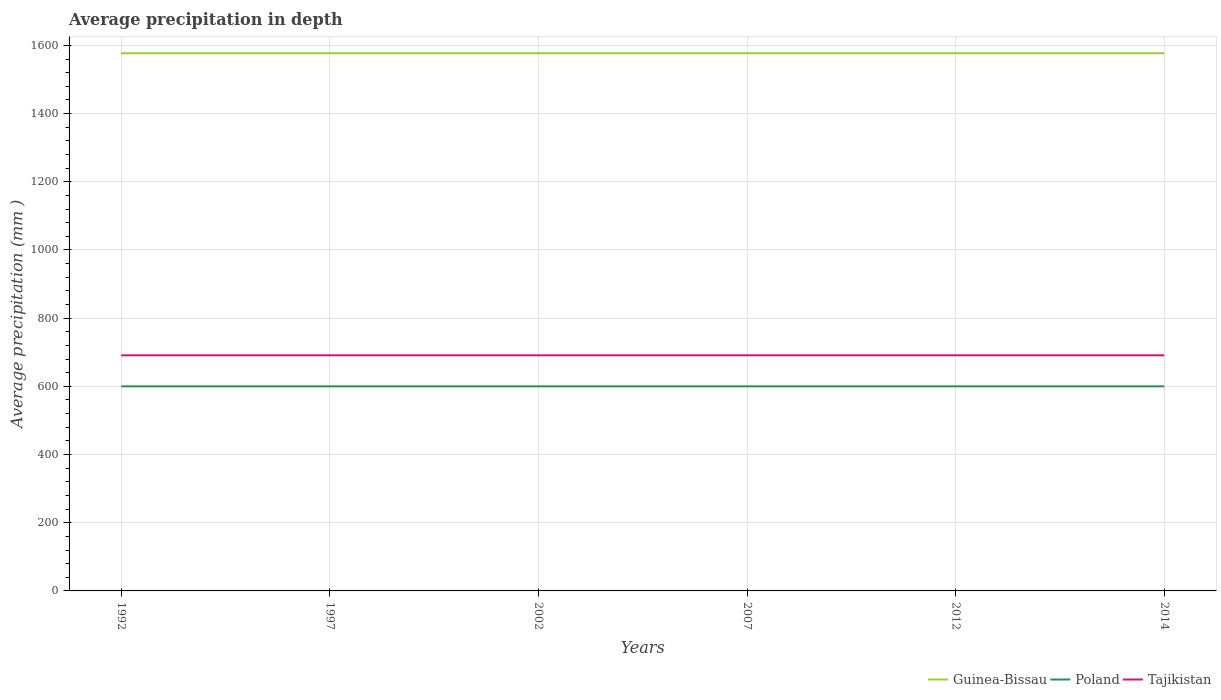How many different coloured lines are there?
Offer a very short reply. 3. Does the line corresponding to Poland intersect with the line corresponding to Tajikistan?
Give a very brief answer. No. Is the number of lines equal to the number of legend labels?
Your answer should be very brief. Yes. Across all years, what is the maximum average precipitation in Tajikistan?
Your answer should be very brief. 691. What is the difference between the highest and the second highest average precipitation in Tajikistan?
Give a very brief answer. 0. What is the difference between the highest and the lowest average precipitation in Poland?
Provide a succinct answer. 0. How many lines are there?
Give a very brief answer. 3. How many years are there in the graph?
Your answer should be very brief. 6. What is the difference between two consecutive major ticks on the Y-axis?
Your answer should be very brief. 200. Does the graph contain any zero values?
Ensure brevity in your answer.  No. Where does the legend appear in the graph?
Provide a short and direct response. Bottom right. How many legend labels are there?
Your response must be concise. 3. How are the legend labels stacked?
Your response must be concise. Horizontal. What is the title of the graph?
Your response must be concise. Average precipitation in depth. What is the label or title of the Y-axis?
Your answer should be very brief. Average precipitation (mm ). What is the Average precipitation (mm ) in Guinea-Bissau in 1992?
Your answer should be very brief. 1577. What is the Average precipitation (mm ) in Poland in 1992?
Provide a succinct answer. 600. What is the Average precipitation (mm ) in Tajikistan in 1992?
Keep it short and to the point. 691. What is the Average precipitation (mm ) in Guinea-Bissau in 1997?
Ensure brevity in your answer.  1577. What is the Average precipitation (mm ) in Poland in 1997?
Provide a short and direct response. 600. What is the Average precipitation (mm ) of Tajikistan in 1997?
Offer a very short reply. 691. What is the Average precipitation (mm ) of Guinea-Bissau in 2002?
Keep it short and to the point. 1577. What is the Average precipitation (mm ) of Poland in 2002?
Your answer should be very brief. 600. What is the Average precipitation (mm ) of Tajikistan in 2002?
Offer a terse response. 691. What is the Average precipitation (mm ) in Guinea-Bissau in 2007?
Keep it short and to the point. 1577. What is the Average precipitation (mm ) of Poland in 2007?
Make the answer very short. 600. What is the Average precipitation (mm ) in Tajikistan in 2007?
Make the answer very short. 691. What is the Average precipitation (mm ) in Guinea-Bissau in 2012?
Give a very brief answer. 1577. What is the Average precipitation (mm ) in Poland in 2012?
Offer a terse response. 600. What is the Average precipitation (mm ) of Tajikistan in 2012?
Your answer should be compact. 691. What is the Average precipitation (mm ) in Guinea-Bissau in 2014?
Keep it short and to the point. 1577. What is the Average precipitation (mm ) of Poland in 2014?
Offer a terse response. 600. What is the Average precipitation (mm ) in Tajikistan in 2014?
Your response must be concise. 691. Across all years, what is the maximum Average precipitation (mm ) in Guinea-Bissau?
Give a very brief answer. 1577. Across all years, what is the maximum Average precipitation (mm ) of Poland?
Offer a very short reply. 600. Across all years, what is the maximum Average precipitation (mm ) in Tajikistan?
Make the answer very short. 691. Across all years, what is the minimum Average precipitation (mm ) of Guinea-Bissau?
Your answer should be compact. 1577. Across all years, what is the minimum Average precipitation (mm ) in Poland?
Your answer should be compact. 600. Across all years, what is the minimum Average precipitation (mm ) in Tajikistan?
Provide a succinct answer. 691. What is the total Average precipitation (mm ) of Guinea-Bissau in the graph?
Offer a very short reply. 9462. What is the total Average precipitation (mm ) of Poland in the graph?
Ensure brevity in your answer.  3600. What is the total Average precipitation (mm ) in Tajikistan in the graph?
Make the answer very short. 4146. What is the difference between the Average precipitation (mm ) of Guinea-Bissau in 1992 and that in 2002?
Provide a short and direct response. 0. What is the difference between the Average precipitation (mm ) of Poland in 1992 and that in 2002?
Provide a succinct answer. 0. What is the difference between the Average precipitation (mm ) of Tajikistan in 1992 and that in 2002?
Make the answer very short. 0. What is the difference between the Average precipitation (mm ) in Poland in 1992 and that in 2007?
Provide a short and direct response. 0. What is the difference between the Average precipitation (mm ) in Tajikistan in 1992 and that in 2007?
Give a very brief answer. 0. What is the difference between the Average precipitation (mm ) in Guinea-Bissau in 1992 and that in 2012?
Offer a very short reply. 0. What is the difference between the Average precipitation (mm ) in Poland in 1992 and that in 2012?
Your answer should be compact. 0. What is the difference between the Average precipitation (mm ) in Tajikistan in 1992 and that in 2012?
Your answer should be very brief. 0. What is the difference between the Average precipitation (mm ) of Guinea-Bissau in 1992 and that in 2014?
Give a very brief answer. 0. What is the difference between the Average precipitation (mm ) in Poland in 1992 and that in 2014?
Provide a short and direct response. 0. What is the difference between the Average precipitation (mm ) of Tajikistan in 1992 and that in 2014?
Make the answer very short. 0. What is the difference between the Average precipitation (mm ) of Guinea-Bissau in 1997 and that in 2002?
Your answer should be very brief. 0. What is the difference between the Average precipitation (mm ) in Poland in 1997 and that in 2007?
Ensure brevity in your answer.  0. What is the difference between the Average precipitation (mm ) of Guinea-Bissau in 1997 and that in 2012?
Provide a succinct answer. 0. What is the difference between the Average precipitation (mm ) of Poland in 1997 and that in 2012?
Provide a short and direct response. 0. What is the difference between the Average precipitation (mm ) in Guinea-Bissau in 1997 and that in 2014?
Offer a terse response. 0. What is the difference between the Average precipitation (mm ) in Poland in 1997 and that in 2014?
Give a very brief answer. 0. What is the difference between the Average precipitation (mm ) of Tajikistan in 1997 and that in 2014?
Keep it short and to the point. 0. What is the difference between the Average precipitation (mm ) in Poland in 2002 and that in 2007?
Your answer should be compact. 0. What is the difference between the Average precipitation (mm ) of Tajikistan in 2002 and that in 2007?
Your answer should be compact. 0. What is the difference between the Average precipitation (mm ) of Guinea-Bissau in 2002 and that in 2012?
Your answer should be compact. 0. What is the difference between the Average precipitation (mm ) in Poland in 2002 and that in 2012?
Keep it short and to the point. 0. What is the difference between the Average precipitation (mm ) in Tajikistan in 2002 and that in 2012?
Provide a succinct answer. 0. What is the difference between the Average precipitation (mm ) of Guinea-Bissau in 2007 and that in 2014?
Provide a succinct answer. 0. What is the difference between the Average precipitation (mm ) of Guinea-Bissau in 1992 and the Average precipitation (mm ) of Poland in 1997?
Provide a succinct answer. 977. What is the difference between the Average precipitation (mm ) of Guinea-Bissau in 1992 and the Average precipitation (mm ) of Tajikistan in 1997?
Give a very brief answer. 886. What is the difference between the Average precipitation (mm ) of Poland in 1992 and the Average precipitation (mm ) of Tajikistan in 1997?
Your answer should be compact. -91. What is the difference between the Average precipitation (mm ) of Guinea-Bissau in 1992 and the Average precipitation (mm ) of Poland in 2002?
Give a very brief answer. 977. What is the difference between the Average precipitation (mm ) of Guinea-Bissau in 1992 and the Average precipitation (mm ) of Tajikistan in 2002?
Your answer should be compact. 886. What is the difference between the Average precipitation (mm ) of Poland in 1992 and the Average precipitation (mm ) of Tajikistan in 2002?
Make the answer very short. -91. What is the difference between the Average precipitation (mm ) of Guinea-Bissau in 1992 and the Average precipitation (mm ) of Poland in 2007?
Offer a terse response. 977. What is the difference between the Average precipitation (mm ) in Guinea-Bissau in 1992 and the Average precipitation (mm ) in Tajikistan in 2007?
Make the answer very short. 886. What is the difference between the Average precipitation (mm ) in Poland in 1992 and the Average precipitation (mm ) in Tajikistan in 2007?
Offer a very short reply. -91. What is the difference between the Average precipitation (mm ) of Guinea-Bissau in 1992 and the Average precipitation (mm ) of Poland in 2012?
Offer a terse response. 977. What is the difference between the Average precipitation (mm ) of Guinea-Bissau in 1992 and the Average precipitation (mm ) of Tajikistan in 2012?
Your answer should be compact. 886. What is the difference between the Average precipitation (mm ) of Poland in 1992 and the Average precipitation (mm ) of Tajikistan in 2012?
Make the answer very short. -91. What is the difference between the Average precipitation (mm ) in Guinea-Bissau in 1992 and the Average precipitation (mm ) in Poland in 2014?
Provide a succinct answer. 977. What is the difference between the Average precipitation (mm ) of Guinea-Bissau in 1992 and the Average precipitation (mm ) of Tajikistan in 2014?
Give a very brief answer. 886. What is the difference between the Average precipitation (mm ) in Poland in 1992 and the Average precipitation (mm ) in Tajikistan in 2014?
Your answer should be compact. -91. What is the difference between the Average precipitation (mm ) in Guinea-Bissau in 1997 and the Average precipitation (mm ) in Poland in 2002?
Make the answer very short. 977. What is the difference between the Average precipitation (mm ) of Guinea-Bissau in 1997 and the Average precipitation (mm ) of Tajikistan in 2002?
Your answer should be very brief. 886. What is the difference between the Average precipitation (mm ) of Poland in 1997 and the Average precipitation (mm ) of Tajikistan in 2002?
Offer a very short reply. -91. What is the difference between the Average precipitation (mm ) in Guinea-Bissau in 1997 and the Average precipitation (mm ) in Poland in 2007?
Ensure brevity in your answer.  977. What is the difference between the Average precipitation (mm ) in Guinea-Bissau in 1997 and the Average precipitation (mm ) in Tajikistan in 2007?
Keep it short and to the point. 886. What is the difference between the Average precipitation (mm ) in Poland in 1997 and the Average precipitation (mm ) in Tajikistan in 2007?
Your response must be concise. -91. What is the difference between the Average precipitation (mm ) in Guinea-Bissau in 1997 and the Average precipitation (mm ) in Poland in 2012?
Provide a succinct answer. 977. What is the difference between the Average precipitation (mm ) in Guinea-Bissau in 1997 and the Average precipitation (mm ) in Tajikistan in 2012?
Ensure brevity in your answer.  886. What is the difference between the Average precipitation (mm ) in Poland in 1997 and the Average precipitation (mm ) in Tajikistan in 2012?
Your response must be concise. -91. What is the difference between the Average precipitation (mm ) in Guinea-Bissau in 1997 and the Average precipitation (mm ) in Poland in 2014?
Provide a succinct answer. 977. What is the difference between the Average precipitation (mm ) of Guinea-Bissau in 1997 and the Average precipitation (mm ) of Tajikistan in 2014?
Keep it short and to the point. 886. What is the difference between the Average precipitation (mm ) in Poland in 1997 and the Average precipitation (mm ) in Tajikistan in 2014?
Ensure brevity in your answer.  -91. What is the difference between the Average precipitation (mm ) of Guinea-Bissau in 2002 and the Average precipitation (mm ) of Poland in 2007?
Keep it short and to the point. 977. What is the difference between the Average precipitation (mm ) in Guinea-Bissau in 2002 and the Average precipitation (mm ) in Tajikistan in 2007?
Keep it short and to the point. 886. What is the difference between the Average precipitation (mm ) of Poland in 2002 and the Average precipitation (mm ) of Tajikistan in 2007?
Ensure brevity in your answer.  -91. What is the difference between the Average precipitation (mm ) of Guinea-Bissau in 2002 and the Average precipitation (mm ) of Poland in 2012?
Your response must be concise. 977. What is the difference between the Average precipitation (mm ) in Guinea-Bissau in 2002 and the Average precipitation (mm ) in Tajikistan in 2012?
Your answer should be very brief. 886. What is the difference between the Average precipitation (mm ) of Poland in 2002 and the Average precipitation (mm ) of Tajikistan in 2012?
Provide a short and direct response. -91. What is the difference between the Average precipitation (mm ) of Guinea-Bissau in 2002 and the Average precipitation (mm ) of Poland in 2014?
Keep it short and to the point. 977. What is the difference between the Average precipitation (mm ) of Guinea-Bissau in 2002 and the Average precipitation (mm ) of Tajikistan in 2014?
Your answer should be very brief. 886. What is the difference between the Average precipitation (mm ) of Poland in 2002 and the Average precipitation (mm ) of Tajikistan in 2014?
Make the answer very short. -91. What is the difference between the Average precipitation (mm ) of Guinea-Bissau in 2007 and the Average precipitation (mm ) of Poland in 2012?
Your answer should be compact. 977. What is the difference between the Average precipitation (mm ) in Guinea-Bissau in 2007 and the Average precipitation (mm ) in Tajikistan in 2012?
Keep it short and to the point. 886. What is the difference between the Average precipitation (mm ) of Poland in 2007 and the Average precipitation (mm ) of Tajikistan in 2012?
Make the answer very short. -91. What is the difference between the Average precipitation (mm ) of Guinea-Bissau in 2007 and the Average precipitation (mm ) of Poland in 2014?
Offer a very short reply. 977. What is the difference between the Average precipitation (mm ) in Guinea-Bissau in 2007 and the Average precipitation (mm ) in Tajikistan in 2014?
Your response must be concise. 886. What is the difference between the Average precipitation (mm ) of Poland in 2007 and the Average precipitation (mm ) of Tajikistan in 2014?
Your response must be concise. -91. What is the difference between the Average precipitation (mm ) in Guinea-Bissau in 2012 and the Average precipitation (mm ) in Poland in 2014?
Keep it short and to the point. 977. What is the difference between the Average precipitation (mm ) of Guinea-Bissau in 2012 and the Average precipitation (mm ) of Tajikistan in 2014?
Offer a terse response. 886. What is the difference between the Average precipitation (mm ) in Poland in 2012 and the Average precipitation (mm ) in Tajikistan in 2014?
Offer a very short reply. -91. What is the average Average precipitation (mm ) of Guinea-Bissau per year?
Your answer should be very brief. 1577. What is the average Average precipitation (mm ) of Poland per year?
Give a very brief answer. 600. What is the average Average precipitation (mm ) of Tajikistan per year?
Offer a very short reply. 691. In the year 1992, what is the difference between the Average precipitation (mm ) in Guinea-Bissau and Average precipitation (mm ) in Poland?
Offer a terse response. 977. In the year 1992, what is the difference between the Average precipitation (mm ) in Guinea-Bissau and Average precipitation (mm ) in Tajikistan?
Your response must be concise. 886. In the year 1992, what is the difference between the Average precipitation (mm ) of Poland and Average precipitation (mm ) of Tajikistan?
Offer a very short reply. -91. In the year 1997, what is the difference between the Average precipitation (mm ) of Guinea-Bissau and Average precipitation (mm ) of Poland?
Make the answer very short. 977. In the year 1997, what is the difference between the Average precipitation (mm ) in Guinea-Bissau and Average precipitation (mm ) in Tajikistan?
Your answer should be very brief. 886. In the year 1997, what is the difference between the Average precipitation (mm ) in Poland and Average precipitation (mm ) in Tajikistan?
Give a very brief answer. -91. In the year 2002, what is the difference between the Average precipitation (mm ) of Guinea-Bissau and Average precipitation (mm ) of Poland?
Your response must be concise. 977. In the year 2002, what is the difference between the Average precipitation (mm ) in Guinea-Bissau and Average precipitation (mm ) in Tajikistan?
Offer a terse response. 886. In the year 2002, what is the difference between the Average precipitation (mm ) in Poland and Average precipitation (mm ) in Tajikistan?
Your answer should be compact. -91. In the year 2007, what is the difference between the Average precipitation (mm ) in Guinea-Bissau and Average precipitation (mm ) in Poland?
Make the answer very short. 977. In the year 2007, what is the difference between the Average precipitation (mm ) in Guinea-Bissau and Average precipitation (mm ) in Tajikistan?
Provide a short and direct response. 886. In the year 2007, what is the difference between the Average precipitation (mm ) of Poland and Average precipitation (mm ) of Tajikistan?
Offer a terse response. -91. In the year 2012, what is the difference between the Average precipitation (mm ) in Guinea-Bissau and Average precipitation (mm ) in Poland?
Offer a very short reply. 977. In the year 2012, what is the difference between the Average precipitation (mm ) in Guinea-Bissau and Average precipitation (mm ) in Tajikistan?
Make the answer very short. 886. In the year 2012, what is the difference between the Average precipitation (mm ) in Poland and Average precipitation (mm ) in Tajikistan?
Make the answer very short. -91. In the year 2014, what is the difference between the Average precipitation (mm ) in Guinea-Bissau and Average precipitation (mm ) in Poland?
Give a very brief answer. 977. In the year 2014, what is the difference between the Average precipitation (mm ) of Guinea-Bissau and Average precipitation (mm ) of Tajikistan?
Your answer should be very brief. 886. In the year 2014, what is the difference between the Average precipitation (mm ) in Poland and Average precipitation (mm ) in Tajikistan?
Provide a short and direct response. -91. What is the ratio of the Average precipitation (mm ) of Guinea-Bissau in 1992 to that in 2002?
Offer a very short reply. 1. What is the ratio of the Average precipitation (mm ) in Poland in 1992 to that in 2002?
Offer a very short reply. 1. What is the ratio of the Average precipitation (mm ) in Tajikistan in 1992 to that in 2002?
Give a very brief answer. 1. What is the ratio of the Average precipitation (mm ) of Poland in 1992 to that in 2007?
Give a very brief answer. 1. What is the ratio of the Average precipitation (mm ) in Guinea-Bissau in 1992 to that in 2012?
Offer a terse response. 1. What is the ratio of the Average precipitation (mm ) of Poland in 1992 to that in 2012?
Provide a short and direct response. 1. What is the ratio of the Average precipitation (mm ) of Tajikistan in 1992 to that in 2012?
Offer a terse response. 1. What is the ratio of the Average precipitation (mm ) of Guinea-Bissau in 1992 to that in 2014?
Offer a terse response. 1. What is the ratio of the Average precipitation (mm ) in Poland in 1992 to that in 2014?
Offer a terse response. 1. What is the ratio of the Average precipitation (mm ) of Tajikistan in 1992 to that in 2014?
Your answer should be very brief. 1. What is the ratio of the Average precipitation (mm ) in Guinea-Bissau in 1997 to that in 2007?
Give a very brief answer. 1. What is the ratio of the Average precipitation (mm ) of Tajikistan in 1997 to that in 2007?
Make the answer very short. 1. What is the ratio of the Average precipitation (mm ) of Tajikistan in 1997 to that in 2012?
Your response must be concise. 1. What is the ratio of the Average precipitation (mm ) in Poland in 1997 to that in 2014?
Your answer should be very brief. 1. What is the ratio of the Average precipitation (mm ) in Tajikistan in 1997 to that in 2014?
Offer a very short reply. 1. What is the ratio of the Average precipitation (mm ) of Guinea-Bissau in 2002 to that in 2007?
Give a very brief answer. 1. What is the ratio of the Average precipitation (mm ) of Poland in 2002 to that in 2007?
Provide a succinct answer. 1. What is the ratio of the Average precipitation (mm ) of Poland in 2002 to that in 2012?
Make the answer very short. 1. What is the ratio of the Average precipitation (mm ) in Guinea-Bissau in 2002 to that in 2014?
Provide a short and direct response. 1. What is the ratio of the Average precipitation (mm ) in Guinea-Bissau in 2007 to that in 2012?
Provide a short and direct response. 1. What is the ratio of the Average precipitation (mm ) of Tajikistan in 2007 to that in 2012?
Offer a terse response. 1. What is the ratio of the Average precipitation (mm ) in Guinea-Bissau in 2007 to that in 2014?
Ensure brevity in your answer.  1. What is the ratio of the Average precipitation (mm ) in Poland in 2007 to that in 2014?
Your answer should be very brief. 1. What is the difference between the highest and the second highest Average precipitation (mm ) in Poland?
Make the answer very short. 0. What is the difference between the highest and the second highest Average precipitation (mm ) of Tajikistan?
Ensure brevity in your answer.  0. What is the difference between the highest and the lowest Average precipitation (mm ) of Guinea-Bissau?
Your response must be concise. 0. What is the difference between the highest and the lowest Average precipitation (mm ) in Tajikistan?
Offer a terse response. 0. 